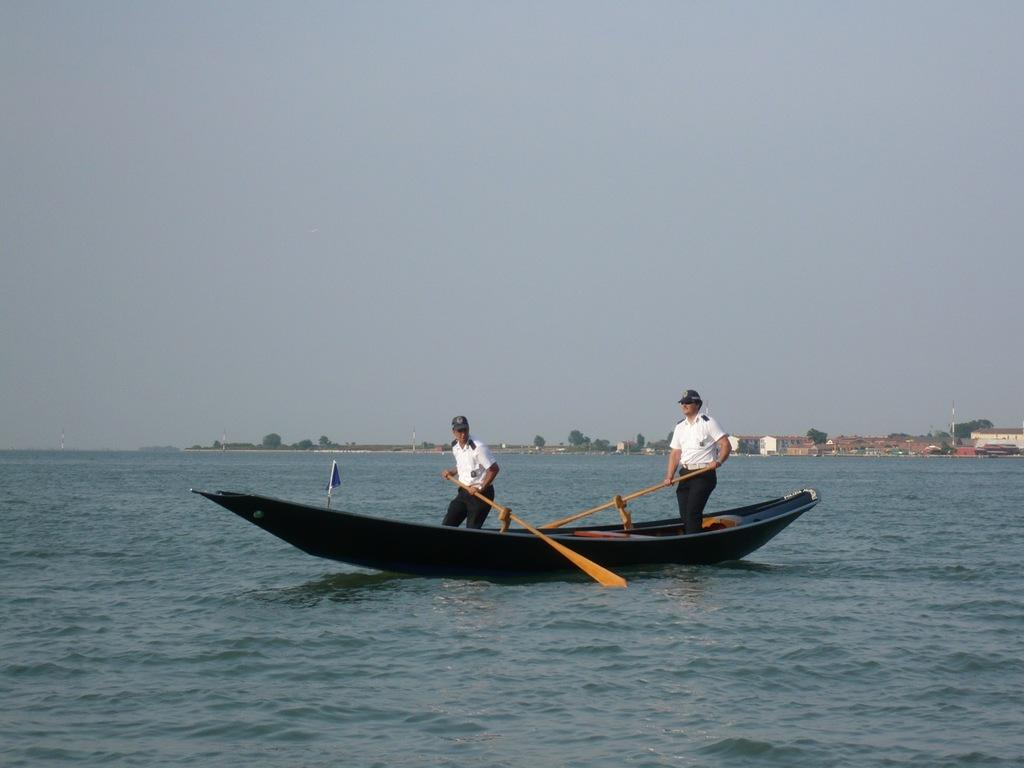What is the main subject of the image? The main subject of the image is a boat. What is the boat doing in the image? The boat is sailing on the water. Who is operating the boat? There are persons rowing the boat. What can be seen in the background of the image? There are trees and buildings in the background of the image. What type of fruit is hanging from the trees in the image? There is no fruit visible in the image; only trees and buildings can be seen in the background. 